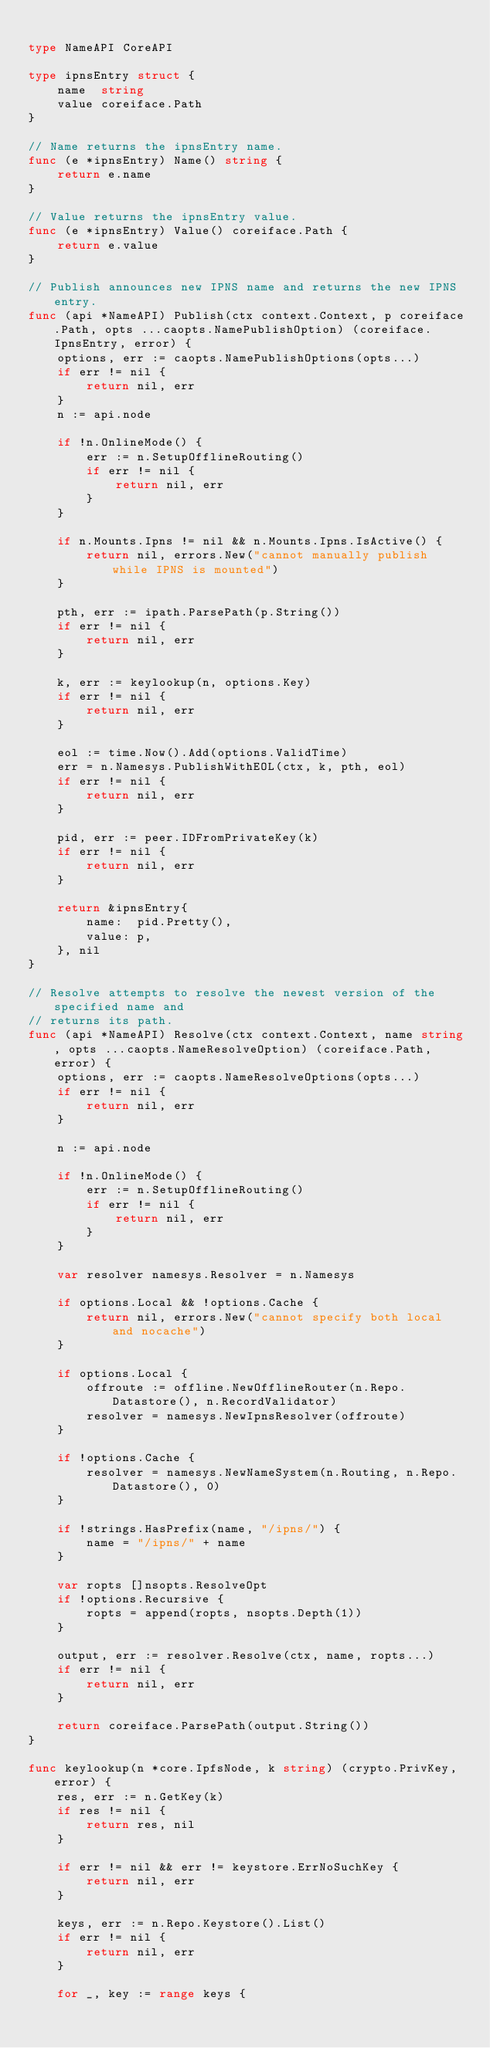<code> <loc_0><loc_0><loc_500><loc_500><_Go_>
type NameAPI CoreAPI

type ipnsEntry struct {
	name  string
	value coreiface.Path
}

// Name returns the ipnsEntry name.
func (e *ipnsEntry) Name() string {
	return e.name
}

// Value returns the ipnsEntry value.
func (e *ipnsEntry) Value() coreiface.Path {
	return e.value
}

// Publish announces new IPNS name and returns the new IPNS entry.
func (api *NameAPI) Publish(ctx context.Context, p coreiface.Path, opts ...caopts.NamePublishOption) (coreiface.IpnsEntry, error) {
	options, err := caopts.NamePublishOptions(opts...)
	if err != nil {
		return nil, err
	}
	n := api.node

	if !n.OnlineMode() {
		err := n.SetupOfflineRouting()
		if err != nil {
			return nil, err
		}
	}

	if n.Mounts.Ipns != nil && n.Mounts.Ipns.IsActive() {
		return nil, errors.New("cannot manually publish while IPNS is mounted")
	}

	pth, err := ipath.ParsePath(p.String())
	if err != nil {
		return nil, err
	}

	k, err := keylookup(n, options.Key)
	if err != nil {
		return nil, err
	}

	eol := time.Now().Add(options.ValidTime)
	err = n.Namesys.PublishWithEOL(ctx, k, pth, eol)
	if err != nil {
		return nil, err
	}

	pid, err := peer.IDFromPrivateKey(k)
	if err != nil {
		return nil, err
	}

	return &ipnsEntry{
		name:  pid.Pretty(),
		value: p,
	}, nil
}

// Resolve attempts to resolve the newest version of the specified name and
// returns its path.
func (api *NameAPI) Resolve(ctx context.Context, name string, opts ...caopts.NameResolveOption) (coreiface.Path, error) {
	options, err := caopts.NameResolveOptions(opts...)
	if err != nil {
		return nil, err
	}

	n := api.node

	if !n.OnlineMode() {
		err := n.SetupOfflineRouting()
		if err != nil {
			return nil, err
		}
	}

	var resolver namesys.Resolver = n.Namesys

	if options.Local && !options.Cache {
		return nil, errors.New("cannot specify both local and nocache")
	}

	if options.Local {
		offroute := offline.NewOfflineRouter(n.Repo.Datastore(), n.RecordValidator)
		resolver = namesys.NewIpnsResolver(offroute)
	}

	if !options.Cache {
		resolver = namesys.NewNameSystem(n.Routing, n.Repo.Datastore(), 0)
	}

	if !strings.HasPrefix(name, "/ipns/") {
		name = "/ipns/" + name
	}

	var ropts []nsopts.ResolveOpt
	if !options.Recursive {
		ropts = append(ropts, nsopts.Depth(1))
	}

	output, err := resolver.Resolve(ctx, name, ropts...)
	if err != nil {
		return nil, err
	}

	return coreiface.ParsePath(output.String())
}

func keylookup(n *core.IpfsNode, k string) (crypto.PrivKey, error) {
	res, err := n.GetKey(k)
	if res != nil {
		return res, nil
	}

	if err != nil && err != keystore.ErrNoSuchKey {
		return nil, err
	}

	keys, err := n.Repo.Keystore().List()
	if err != nil {
		return nil, err
	}

	for _, key := range keys {</code> 